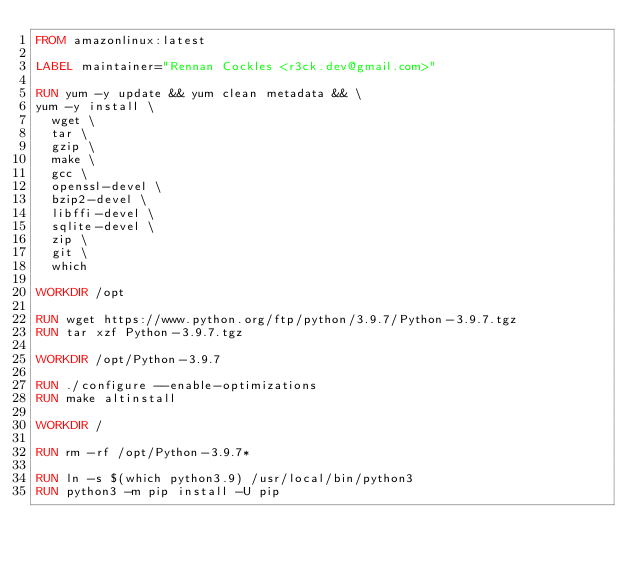Convert code to text. <code><loc_0><loc_0><loc_500><loc_500><_Dockerfile_>FROM amazonlinux:latest

LABEL maintainer="Rennan Cockles <r3ck.dev@gmail.com>"

RUN yum -y update && yum clean metadata && \
yum -y install \
  wget \
  tar \
  gzip \
  make \
  gcc \
  openssl-devel \
  bzip2-devel \
  libffi-devel \
  sqlite-devel \
  zip \
  git \
  which

WORKDIR /opt

RUN wget https://www.python.org/ftp/python/3.9.7/Python-3.9.7.tgz
RUN tar xzf Python-3.9.7.tgz

WORKDIR /opt/Python-3.9.7

RUN ./configure --enable-optimizations
RUN make altinstall

WORKDIR /

RUN rm -rf /opt/Python-3.9.7*

RUN ln -s $(which python3.9) /usr/local/bin/python3
RUN python3 -m pip install -U pip
</code> 